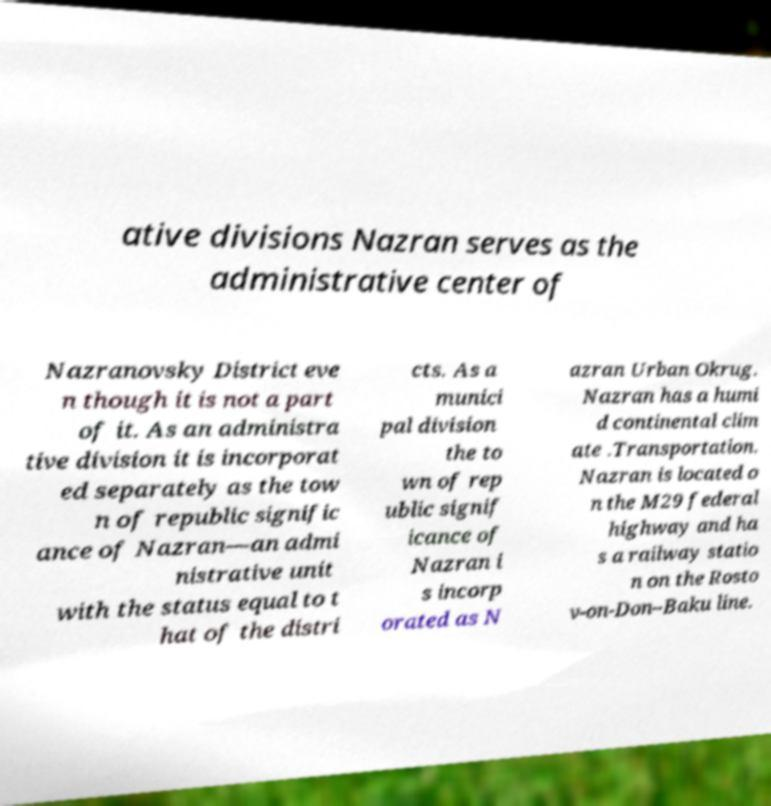Can you accurately transcribe the text from the provided image for me? ative divisions Nazran serves as the administrative center of Nazranovsky District eve n though it is not a part of it. As an administra tive division it is incorporat ed separately as the tow n of republic signific ance of Nazran—an admi nistrative unit with the status equal to t hat of the distri cts. As a munici pal division the to wn of rep ublic signif icance of Nazran i s incorp orated as N azran Urban Okrug. Nazran has a humi d continental clim ate .Transportation. Nazran is located o n the M29 federal highway and ha s a railway statio n on the Rosto v-on-Don–Baku line. 